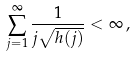Convert formula to latex. <formula><loc_0><loc_0><loc_500><loc_500>\sum _ { j = 1 } ^ { \infty } \frac { 1 } { j \sqrt { h ( j ) } } < \infty \, ,</formula> 